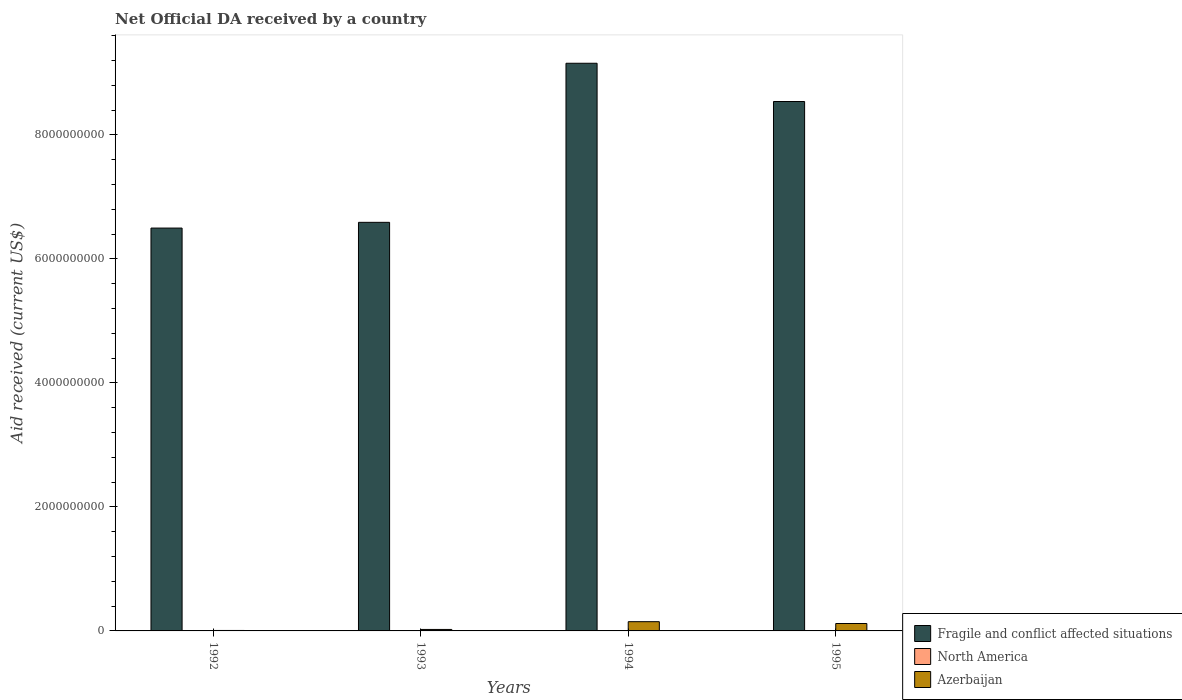How many groups of bars are there?
Offer a terse response. 4. Are the number of bars on each tick of the X-axis equal?
Your response must be concise. Yes. What is the label of the 4th group of bars from the left?
Your answer should be compact. 1995. What is the net official development assistance aid received in Azerbaijan in 1992?
Your response must be concise. 7.43e+06. Across all years, what is the maximum net official development assistance aid received in Azerbaijan?
Ensure brevity in your answer.  1.49e+08. Across all years, what is the minimum net official development assistance aid received in Fragile and conflict affected situations?
Ensure brevity in your answer.  6.50e+09. In which year was the net official development assistance aid received in Fragile and conflict affected situations maximum?
Give a very brief answer. 1994. What is the total net official development assistance aid received in Fragile and conflict affected situations in the graph?
Your answer should be very brief. 3.08e+1. What is the difference between the net official development assistance aid received in Azerbaijan in 1993 and that in 1995?
Ensure brevity in your answer.  -9.57e+07. What is the difference between the net official development assistance aid received in Fragile and conflict affected situations in 1993 and the net official development assistance aid received in North America in 1994?
Give a very brief answer. 6.59e+09. What is the average net official development assistance aid received in North America per year?
Ensure brevity in your answer.  0. In the year 1993, what is the difference between the net official development assistance aid received in Fragile and conflict affected situations and net official development assistance aid received in Azerbaijan?
Offer a terse response. 6.57e+09. In how many years, is the net official development assistance aid received in Fragile and conflict affected situations greater than 6400000000 US$?
Your response must be concise. 4. What is the ratio of the net official development assistance aid received in Fragile and conflict affected situations in 1992 to that in 1995?
Your answer should be very brief. 0.76. What is the difference between the highest and the second highest net official development assistance aid received in Azerbaijan?
Ensure brevity in your answer.  2.95e+07. What is the difference between the highest and the lowest net official development assistance aid received in Azerbaijan?
Your answer should be very brief. 1.42e+08. In how many years, is the net official development assistance aid received in North America greater than the average net official development assistance aid received in North America taken over all years?
Your answer should be compact. 0. Are all the bars in the graph horizontal?
Offer a terse response. No. How many years are there in the graph?
Offer a terse response. 4. What is the difference between two consecutive major ticks on the Y-axis?
Offer a very short reply. 2.00e+09. Does the graph contain any zero values?
Your response must be concise. Yes. Where does the legend appear in the graph?
Give a very brief answer. Bottom right. What is the title of the graph?
Offer a very short reply. Net Official DA received by a country. What is the label or title of the X-axis?
Your answer should be very brief. Years. What is the label or title of the Y-axis?
Offer a terse response. Aid received (current US$). What is the Aid received (current US$) of Fragile and conflict affected situations in 1992?
Offer a very short reply. 6.50e+09. What is the Aid received (current US$) in North America in 1992?
Give a very brief answer. 0. What is the Aid received (current US$) of Azerbaijan in 1992?
Give a very brief answer. 7.43e+06. What is the Aid received (current US$) of Fragile and conflict affected situations in 1993?
Your answer should be very brief. 6.59e+09. What is the Aid received (current US$) of North America in 1993?
Keep it short and to the point. 0. What is the Aid received (current US$) of Azerbaijan in 1993?
Give a very brief answer. 2.39e+07. What is the Aid received (current US$) of Fragile and conflict affected situations in 1994?
Your answer should be compact. 9.16e+09. What is the Aid received (current US$) of Azerbaijan in 1994?
Offer a very short reply. 1.49e+08. What is the Aid received (current US$) in Fragile and conflict affected situations in 1995?
Give a very brief answer. 8.54e+09. What is the Aid received (current US$) of Azerbaijan in 1995?
Keep it short and to the point. 1.20e+08. Across all years, what is the maximum Aid received (current US$) of Fragile and conflict affected situations?
Your answer should be compact. 9.16e+09. Across all years, what is the maximum Aid received (current US$) in Azerbaijan?
Provide a short and direct response. 1.49e+08. Across all years, what is the minimum Aid received (current US$) in Fragile and conflict affected situations?
Provide a short and direct response. 6.50e+09. Across all years, what is the minimum Aid received (current US$) in Azerbaijan?
Ensure brevity in your answer.  7.43e+06. What is the total Aid received (current US$) of Fragile and conflict affected situations in the graph?
Provide a succinct answer. 3.08e+1. What is the total Aid received (current US$) of North America in the graph?
Give a very brief answer. 0. What is the total Aid received (current US$) of Azerbaijan in the graph?
Provide a short and direct response. 3.00e+08. What is the difference between the Aid received (current US$) in Fragile and conflict affected situations in 1992 and that in 1993?
Offer a very short reply. -9.26e+07. What is the difference between the Aid received (current US$) of Azerbaijan in 1992 and that in 1993?
Provide a short and direct response. -1.64e+07. What is the difference between the Aid received (current US$) in Fragile and conflict affected situations in 1992 and that in 1994?
Offer a terse response. -2.66e+09. What is the difference between the Aid received (current US$) in Azerbaijan in 1992 and that in 1994?
Keep it short and to the point. -1.42e+08. What is the difference between the Aid received (current US$) of Fragile and conflict affected situations in 1992 and that in 1995?
Make the answer very short. -2.04e+09. What is the difference between the Aid received (current US$) in Azerbaijan in 1992 and that in 1995?
Keep it short and to the point. -1.12e+08. What is the difference between the Aid received (current US$) in Fragile and conflict affected situations in 1993 and that in 1994?
Your answer should be very brief. -2.57e+09. What is the difference between the Aid received (current US$) in Azerbaijan in 1993 and that in 1994?
Offer a very short reply. -1.25e+08. What is the difference between the Aid received (current US$) in Fragile and conflict affected situations in 1993 and that in 1995?
Give a very brief answer. -1.95e+09. What is the difference between the Aid received (current US$) of Azerbaijan in 1993 and that in 1995?
Provide a short and direct response. -9.57e+07. What is the difference between the Aid received (current US$) in Fragile and conflict affected situations in 1994 and that in 1995?
Offer a very short reply. 6.17e+08. What is the difference between the Aid received (current US$) of Azerbaijan in 1994 and that in 1995?
Keep it short and to the point. 2.95e+07. What is the difference between the Aid received (current US$) in Fragile and conflict affected situations in 1992 and the Aid received (current US$) in Azerbaijan in 1993?
Provide a short and direct response. 6.47e+09. What is the difference between the Aid received (current US$) of Fragile and conflict affected situations in 1992 and the Aid received (current US$) of Azerbaijan in 1994?
Keep it short and to the point. 6.35e+09. What is the difference between the Aid received (current US$) in Fragile and conflict affected situations in 1992 and the Aid received (current US$) in Azerbaijan in 1995?
Ensure brevity in your answer.  6.38e+09. What is the difference between the Aid received (current US$) in Fragile and conflict affected situations in 1993 and the Aid received (current US$) in Azerbaijan in 1994?
Offer a terse response. 6.44e+09. What is the difference between the Aid received (current US$) in Fragile and conflict affected situations in 1993 and the Aid received (current US$) in Azerbaijan in 1995?
Your answer should be compact. 6.47e+09. What is the difference between the Aid received (current US$) of Fragile and conflict affected situations in 1994 and the Aid received (current US$) of Azerbaijan in 1995?
Offer a very short reply. 9.04e+09. What is the average Aid received (current US$) in Fragile and conflict affected situations per year?
Make the answer very short. 7.70e+09. What is the average Aid received (current US$) of Azerbaijan per year?
Offer a very short reply. 7.50e+07. In the year 1992, what is the difference between the Aid received (current US$) in Fragile and conflict affected situations and Aid received (current US$) in Azerbaijan?
Provide a short and direct response. 6.49e+09. In the year 1993, what is the difference between the Aid received (current US$) in Fragile and conflict affected situations and Aid received (current US$) in Azerbaijan?
Offer a very short reply. 6.57e+09. In the year 1994, what is the difference between the Aid received (current US$) in Fragile and conflict affected situations and Aid received (current US$) in Azerbaijan?
Provide a short and direct response. 9.01e+09. In the year 1995, what is the difference between the Aid received (current US$) in Fragile and conflict affected situations and Aid received (current US$) in Azerbaijan?
Make the answer very short. 8.42e+09. What is the ratio of the Aid received (current US$) in Fragile and conflict affected situations in 1992 to that in 1993?
Keep it short and to the point. 0.99. What is the ratio of the Aid received (current US$) in Azerbaijan in 1992 to that in 1993?
Give a very brief answer. 0.31. What is the ratio of the Aid received (current US$) in Fragile and conflict affected situations in 1992 to that in 1994?
Keep it short and to the point. 0.71. What is the ratio of the Aid received (current US$) of Azerbaijan in 1992 to that in 1994?
Make the answer very short. 0.05. What is the ratio of the Aid received (current US$) of Fragile and conflict affected situations in 1992 to that in 1995?
Give a very brief answer. 0.76. What is the ratio of the Aid received (current US$) of Azerbaijan in 1992 to that in 1995?
Give a very brief answer. 0.06. What is the ratio of the Aid received (current US$) of Fragile and conflict affected situations in 1993 to that in 1994?
Your response must be concise. 0.72. What is the ratio of the Aid received (current US$) of Azerbaijan in 1993 to that in 1994?
Your response must be concise. 0.16. What is the ratio of the Aid received (current US$) in Fragile and conflict affected situations in 1993 to that in 1995?
Provide a short and direct response. 0.77. What is the ratio of the Aid received (current US$) of Azerbaijan in 1993 to that in 1995?
Keep it short and to the point. 0.2. What is the ratio of the Aid received (current US$) in Fragile and conflict affected situations in 1994 to that in 1995?
Your answer should be very brief. 1.07. What is the ratio of the Aid received (current US$) in Azerbaijan in 1994 to that in 1995?
Give a very brief answer. 1.25. What is the difference between the highest and the second highest Aid received (current US$) of Fragile and conflict affected situations?
Give a very brief answer. 6.17e+08. What is the difference between the highest and the second highest Aid received (current US$) of Azerbaijan?
Give a very brief answer. 2.95e+07. What is the difference between the highest and the lowest Aid received (current US$) of Fragile and conflict affected situations?
Your response must be concise. 2.66e+09. What is the difference between the highest and the lowest Aid received (current US$) of Azerbaijan?
Offer a terse response. 1.42e+08. 